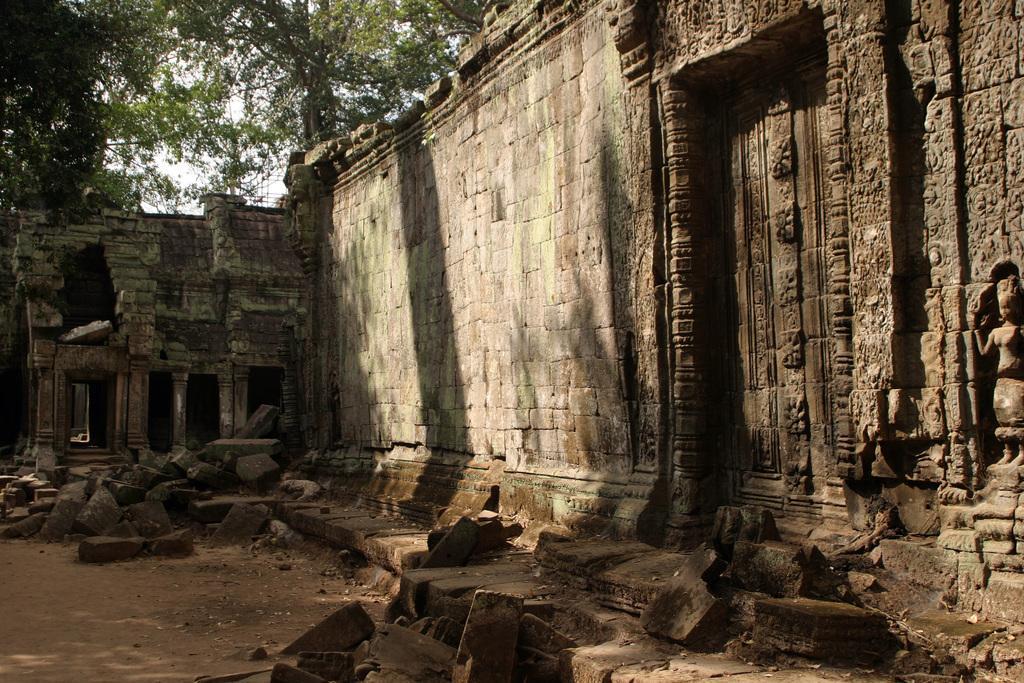Please provide a concise description of this image. In this image I can see number of stones on the ground. On the right side and in the background I can see the wall. On the top left side of this image I can see few trees. 